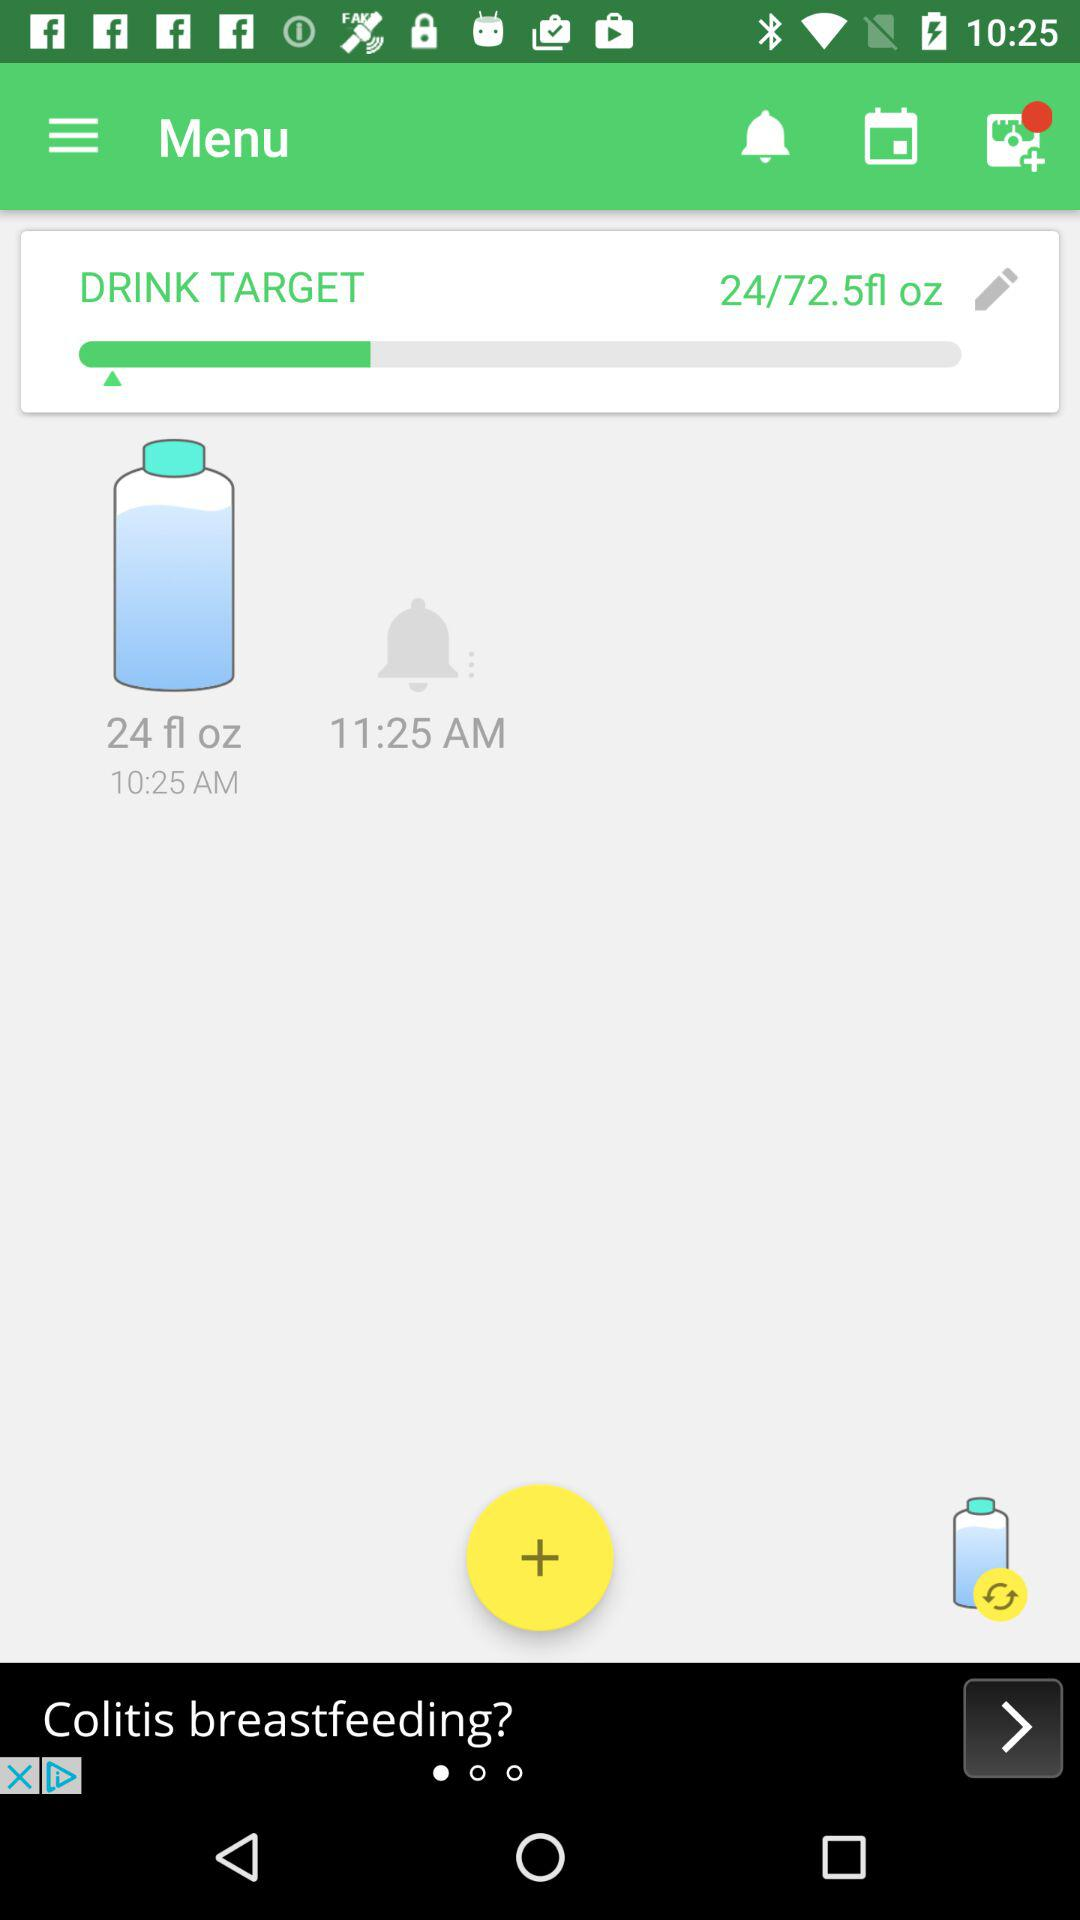What is the maximum drink target? The maximum drink target is 72.5 fl oz. 